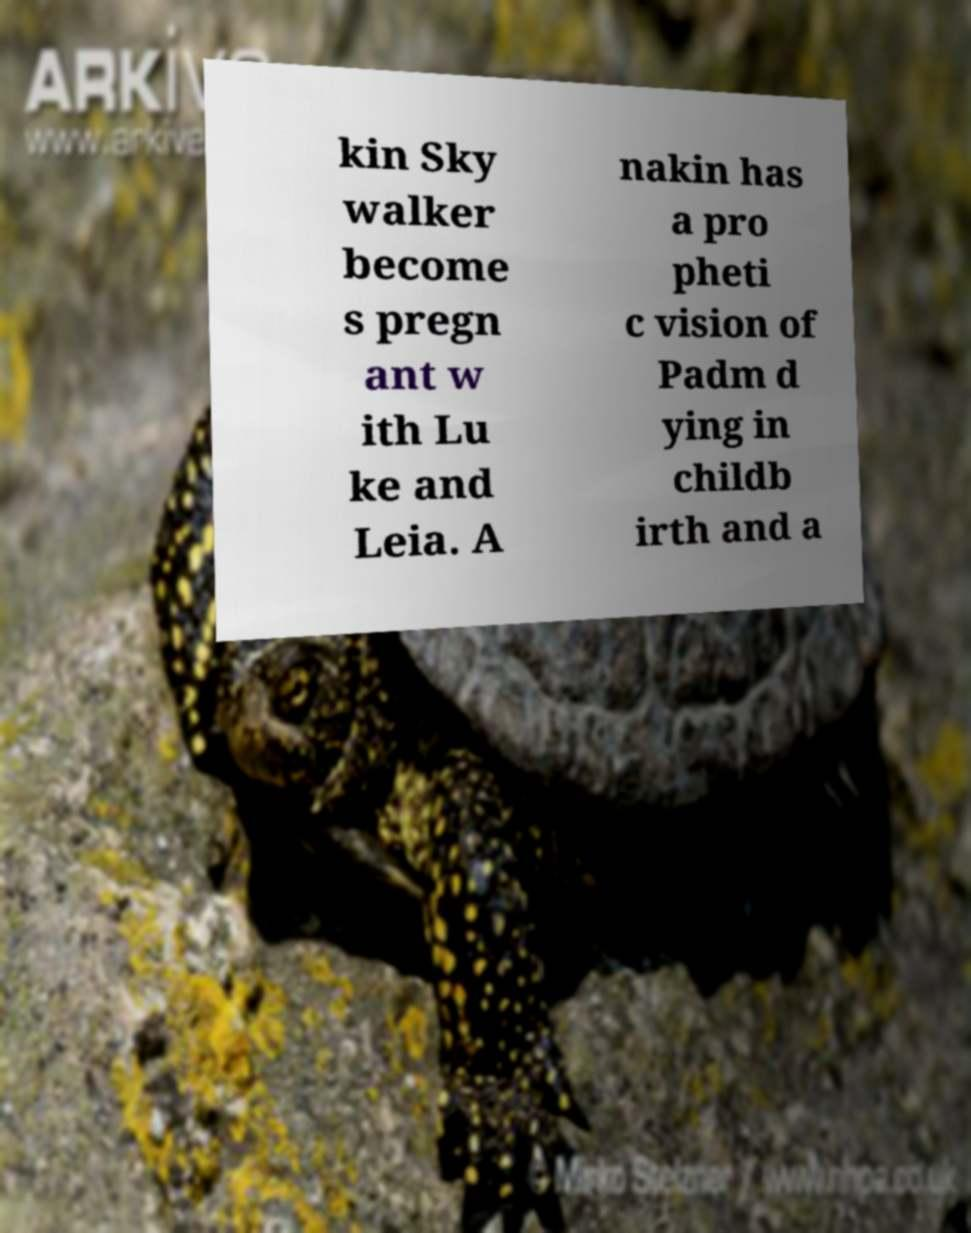For documentation purposes, I need the text within this image transcribed. Could you provide that? kin Sky walker become s pregn ant w ith Lu ke and Leia. A nakin has a pro pheti c vision of Padm d ying in childb irth and a 